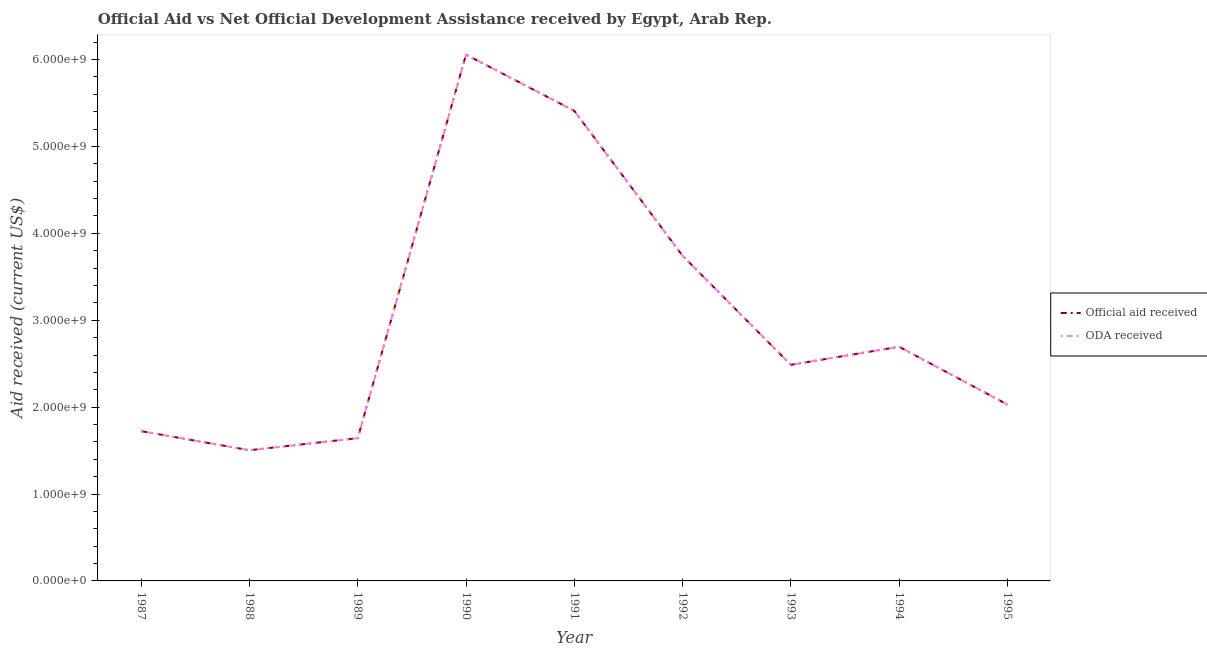Does the line corresponding to oda received intersect with the line corresponding to official aid received?
Provide a short and direct response. Yes. Is the number of lines equal to the number of legend labels?
Provide a succinct answer. Yes. What is the official aid received in 1992?
Offer a terse response. 3.74e+09. Across all years, what is the maximum oda received?
Provide a succinct answer. 6.06e+09. Across all years, what is the minimum oda received?
Offer a very short reply. 1.50e+09. In which year was the official aid received maximum?
Provide a short and direct response. 1990. In which year was the official aid received minimum?
Your answer should be very brief. 1988. What is the total oda received in the graph?
Your response must be concise. 2.73e+1. What is the difference between the official aid received in 1989 and that in 1993?
Your response must be concise. -8.44e+08. What is the difference between the oda received in 1990 and the official aid received in 1987?
Your response must be concise. 4.33e+09. What is the average oda received per year?
Ensure brevity in your answer.  3.03e+09. In the year 1989, what is the difference between the oda received and official aid received?
Ensure brevity in your answer.  0. What is the ratio of the oda received in 1989 to that in 1991?
Provide a short and direct response. 0.3. Is the official aid received in 1991 less than that in 1994?
Offer a terse response. No. What is the difference between the highest and the second highest official aid received?
Offer a terse response. 6.46e+08. What is the difference between the highest and the lowest oda received?
Keep it short and to the point. 4.55e+09. In how many years, is the official aid received greater than the average official aid received taken over all years?
Keep it short and to the point. 3. Is the sum of the official aid received in 1989 and 1992 greater than the maximum oda received across all years?
Make the answer very short. No. Does the oda received monotonically increase over the years?
Provide a short and direct response. No. Is the official aid received strictly greater than the oda received over the years?
Keep it short and to the point. No. Are the values on the major ticks of Y-axis written in scientific E-notation?
Provide a succinct answer. Yes. Does the graph contain grids?
Ensure brevity in your answer.  No. What is the title of the graph?
Ensure brevity in your answer.  Official Aid vs Net Official Development Assistance received by Egypt, Arab Rep. . What is the label or title of the X-axis?
Give a very brief answer. Year. What is the label or title of the Y-axis?
Offer a very short reply. Aid received (current US$). What is the Aid received (current US$) of Official aid received in 1987?
Your response must be concise. 1.72e+09. What is the Aid received (current US$) in ODA received in 1987?
Give a very brief answer. 1.72e+09. What is the Aid received (current US$) in Official aid received in 1988?
Give a very brief answer. 1.50e+09. What is the Aid received (current US$) of ODA received in 1988?
Provide a short and direct response. 1.50e+09. What is the Aid received (current US$) of Official aid received in 1989?
Your answer should be compact. 1.64e+09. What is the Aid received (current US$) of ODA received in 1989?
Your answer should be compact. 1.64e+09. What is the Aid received (current US$) of Official aid received in 1990?
Keep it short and to the point. 6.06e+09. What is the Aid received (current US$) of ODA received in 1990?
Make the answer very short. 6.06e+09. What is the Aid received (current US$) in Official aid received in 1991?
Ensure brevity in your answer.  5.41e+09. What is the Aid received (current US$) of ODA received in 1991?
Keep it short and to the point. 5.41e+09. What is the Aid received (current US$) in Official aid received in 1992?
Offer a terse response. 3.74e+09. What is the Aid received (current US$) in ODA received in 1992?
Offer a terse response. 3.74e+09. What is the Aid received (current US$) of Official aid received in 1993?
Offer a terse response. 2.49e+09. What is the Aid received (current US$) in ODA received in 1993?
Your answer should be very brief. 2.49e+09. What is the Aid received (current US$) of Official aid received in 1994?
Keep it short and to the point. 2.69e+09. What is the Aid received (current US$) of ODA received in 1994?
Your answer should be very brief. 2.69e+09. What is the Aid received (current US$) in Official aid received in 1995?
Offer a terse response. 2.03e+09. What is the Aid received (current US$) of ODA received in 1995?
Give a very brief answer. 2.03e+09. Across all years, what is the maximum Aid received (current US$) in Official aid received?
Your answer should be very brief. 6.06e+09. Across all years, what is the maximum Aid received (current US$) of ODA received?
Provide a succinct answer. 6.06e+09. Across all years, what is the minimum Aid received (current US$) in Official aid received?
Your answer should be very brief. 1.50e+09. Across all years, what is the minimum Aid received (current US$) of ODA received?
Offer a very short reply. 1.50e+09. What is the total Aid received (current US$) in Official aid received in the graph?
Your answer should be very brief. 2.73e+1. What is the total Aid received (current US$) in ODA received in the graph?
Your answer should be compact. 2.73e+1. What is the difference between the Aid received (current US$) in Official aid received in 1987 and that in 1988?
Your response must be concise. 2.19e+08. What is the difference between the Aid received (current US$) of ODA received in 1987 and that in 1988?
Your answer should be very brief. 2.19e+08. What is the difference between the Aid received (current US$) of Official aid received in 1987 and that in 1989?
Make the answer very short. 8.04e+07. What is the difference between the Aid received (current US$) of ODA received in 1987 and that in 1989?
Offer a terse response. 8.04e+07. What is the difference between the Aid received (current US$) in Official aid received in 1987 and that in 1990?
Provide a succinct answer. -4.33e+09. What is the difference between the Aid received (current US$) of ODA received in 1987 and that in 1990?
Your answer should be compact. -4.33e+09. What is the difference between the Aid received (current US$) of Official aid received in 1987 and that in 1991?
Provide a succinct answer. -3.69e+09. What is the difference between the Aid received (current US$) of ODA received in 1987 and that in 1991?
Your response must be concise. -3.69e+09. What is the difference between the Aid received (current US$) of Official aid received in 1987 and that in 1992?
Give a very brief answer. -2.02e+09. What is the difference between the Aid received (current US$) in ODA received in 1987 and that in 1992?
Make the answer very short. -2.02e+09. What is the difference between the Aid received (current US$) of Official aid received in 1987 and that in 1993?
Offer a very short reply. -7.63e+08. What is the difference between the Aid received (current US$) of ODA received in 1987 and that in 1993?
Offer a very short reply. -7.63e+08. What is the difference between the Aid received (current US$) in Official aid received in 1987 and that in 1994?
Ensure brevity in your answer.  -9.71e+08. What is the difference between the Aid received (current US$) in ODA received in 1987 and that in 1994?
Offer a very short reply. -9.71e+08. What is the difference between the Aid received (current US$) in Official aid received in 1987 and that in 1995?
Your answer should be very brief. -3.06e+08. What is the difference between the Aid received (current US$) of ODA received in 1987 and that in 1995?
Your response must be concise. -3.06e+08. What is the difference between the Aid received (current US$) in Official aid received in 1988 and that in 1989?
Your response must be concise. -1.39e+08. What is the difference between the Aid received (current US$) of ODA received in 1988 and that in 1989?
Provide a succinct answer. -1.39e+08. What is the difference between the Aid received (current US$) of Official aid received in 1988 and that in 1990?
Keep it short and to the point. -4.55e+09. What is the difference between the Aid received (current US$) of ODA received in 1988 and that in 1990?
Keep it short and to the point. -4.55e+09. What is the difference between the Aid received (current US$) of Official aid received in 1988 and that in 1991?
Your answer should be very brief. -3.91e+09. What is the difference between the Aid received (current US$) of ODA received in 1988 and that in 1991?
Provide a succinct answer. -3.91e+09. What is the difference between the Aid received (current US$) of Official aid received in 1988 and that in 1992?
Offer a terse response. -2.24e+09. What is the difference between the Aid received (current US$) in ODA received in 1988 and that in 1992?
Your answer should be very brief. -2.24e+09. What is the difference between the Aid received (current US$) of Official aid received in 1988 and that in 1993?
Ensure brevity in your answer.  -9.83e+08. What is the difference between the Aid received (current US$) of ODA received in 1988 and that in 1993?
Keep it short and to the point. -9.83e+08. What is the difference between the Aid received (current US$) of Official aid received in 1988 and that in 1994?
Your response must be concise. -1.19e+09. What is the difference between the Aid received (current US$) of ODA received in 1988 and that in 1994?
Offer a terse response. -1.19e+09. What is the difference between the Aid received (current US$) in Official aid received in 1988 and that in 1995?
Your answer should be very brief. -5.26e+08. What is the difference between the Aid received (current US$) of ODA received in 1988 and that in 1995?
Your answer should be compact. -5.26e+08. What is the difference between the Aid received (current US$) of Official aid received in 1989 and that in 1990?
Offer a very short reply. -4.41e+09. What is the difference between the Aid received (current US$) of ODA received in 1989 and that in 1990?
Offer a very short reply. -4.41e+09. What is the difference between the Aid received (current US$) in Official aid received in 1989 and that in 1991?
Your answer should be compact. -3.77e+09. What is the difference between the Aid received (current US$) in ODA received in 1989 and that in 1991?
Your response must be concise. -3.77e+09. What is the difference between the Aid received (current US$) in Official aid received in 1989 and that in 1992?
Offer a very short reply. -2.10e+09. What is the difference between the Aid received (current US$) of ODA received in 1989 and that in 1992?
Offer a very short reply. -2.10e+09. What is the difference between the Aid received (current US$) in Official aid received in 1989 and that in 1993?
Ensure brevity in your answer.  -8.44e+08. What is the difference between the Aid received (current US$) in ODA received in 1989 and that in 1993?
Give a very brief answer. -8.44e+08. What is the difference between the Aid received (current US$) in Official aid received in 1989 and that in 1994?
Offer a terse response. -1.05e+09. What is the difference between the Aid received (current US$) of ODA received in 1989 and that in 1994?
Ensure brevity in your answer.  -1.05e+09. What is the difference between the Aid received (current US$) in Official aid received in 1989 and that in 1995?
Your answer should be compact. -3.87e+08. What is the difference between the Aid received (current US$) of ODA received in 1989 and that in 1995?
Your answer should be very brief. -3.87e+08. What is the difference between the Aid received (current US$) of Official aid received in 1990 and that in 1991?
Your answer should be compact. 6.46e+08. What is the difference between the Aid received (current US$) of ODA received in 1990 and that in 1991?
Your answer should be compact. 6.46e+08. What is the difference between the Aid received (current US$) in Official aid received in 1990 and that in 1992?
Offer a very short reply. 2.31e+09. What is the difference between the Aid received (current US$) of ODA received in 1990 and that in 1992?
Your answer should be very brief. 2.31e+09. What is the difference between the Aid received (current US$) of Official aid received in 1990 and that in 1993?
Your answer should be very brief. 3.57e+09. What is the difference between the Aid received (current US$) of ODA received in 1990 and that in 1993?
Offer a very short reply. 3.57e+09. What is the difference between the Aid received (current US$) in Official aid received in 1990 and that in 1994?
Provide a succinct answer. 3.36e+09. What is the difference between the Aid received (current US$) in ODA received in 1990 and that in 1994?
Your response must be concise. 3.36e+09. What is the difference between the Aid received (current US$) of Official aid received in 1990 and that in 1995?
Keep it short and to the point. 4.03e+09. What is the difference between the Aid received (current US$) of ODA received in 1990 and that in 1995?
Provide a short and direct response. 4.03e+09. What is the difference between the Aid received (current US$) of Official aid received in 1991 and that in 1992?
Provide a short and direct response. 1.67e+09. What is the difference between the Aid received (current US$) of ODA received in 1991 and that in 1992?
Give a very brief answer. 1.67e+09. What is the difference between the Aid received (current US$) of Official aid received in 1991 and that in 1993?
Give a very brief answer. 2.92e+09. What is the difference between the Aid received (current US$) of ODA received in 1991 and that in 1993?
Give a very brief answer. 2.92e+09. What is the difference between the Aid received (current US$) in Official aid received in 1991 and that in 1994?
Your response must be concise. 2.72e+09. What is the difference between the Aid received (current US$) of ODA received in 1991 and that in 1994?
Your response must be concise. 2.72e+09. What is the difference between the Aid received (current US$) in Official aid received in 1991 and that in 1995?
Provide a succinct answer. 3.38e+09. What is the difference between the Aid received (current US$) of ODA received in 1991 and that in 1995?
Provide a succinct answer. 3.38e+09. What is the difference between the Aid received (current US$) in Official aid received in 1992 and that in 1993?
Provide a succinct answer. 1.26e+09. What is the difference between the Aid received (current US$) in ODA received in 1992 and that in 1993?
Your answer should be compact. 1.26e+09. What is the difference between the Aid received (current US$) of Official aid received in 1992 and that in 1994?
Your answer should be compact. 1.05e+09. What is the difference between the Aid received (current US$) of ODA received in 1992 and that in 1994?
Provide a short and direct response. 1.05e+09. What is the difference between the Aid received (current US$) of Official aid received in 1992 and that in 1995?
Your response must be concise. 1.71e+09. What is the difference between the Aid received (current US$) of ODA received in 1992 and that in 1995?
Your response must be concise. 1.71e+09. What is the difference between the Aid received (current US$) of Official aid received in 1993 and that in 1994?
Provide a succinct answer. -2.08e+08. What is the difference between the Aid received (current US$) of ODA received in 1993 and that in 1994?
Your answer should be compact. -2.08e+08. What is the difference between the Aid received (current US$) in Official aid received in 1993 and that in 1995?
Provide a short and direct response. 4.57e+08. What is the difference between the Aid received (current US$) in ODA received in 1993 and that in 1995?
Offer a very short reply. 4.57e+08. What is the difference between the Aid received (current US$) of Official aid received in 1994 and that in 1995?
Provide a succinct answer. 6.65e+08. What is the difference between the Aid received (current US$) of ODA received in 1994 and that in 1995?
Give a very brief answer. 6.65e+08. What is the difference between the Aid received (current US$) in Official aid received in 1987 and the Aid received (current US$) in ODA received in 1988?
Your answer should be very brief. 2.19e+08. What is the difference between the Aid received (current US$) of Official aid received in 1987 and the Aid received (current US$) of ODA received in 1989?
Provide a short and direct response. 8.04e+07. What is the difference between the Aid received (current US$) of Official aid received in 1987 and the Aid received (current US$) of ODA received in 1990?
Give a very brief answer. -4.33e+09. What is the difference between the Aid received (current US$) of Official aid received in 1987 and the Aid received (current US$) of ODA received in 1991?
Your response must be concise. -3.69e+09. What is the difference between the Aid received (current US$) of Official aid received in 1987 and the Aid received (current US$) of ODA received in 1992?
Give a very brief answer. -2.02e+09. What is the difference between the Aid received (current US$) in Official aid received in 1987 and the Aid received (current US$) in ODA received in 1993?
Your answer should be very brief. -7.63e+08. What is the difference between the Aid received (current US$) of Official aid received in 1987 and the Aid received (current US$) of ODA received in 1994?
Provide a succinct answer. -9.71e+08. What is the difference between the Aid received (current US$) of Official aid received in 1987 and the Aid received (current US$) of ODA received in 1995?
Offer a terse response. -3.06e+08. What is the difference between the Aid received (current US$) of Official aid received in 1988 and the Aid received (current US$) of ODA received in 1989?
Offer a very short reply. -1.39e+08. What is the difference between the Aid received (current US$) in Official aid received in 1988 and the Aid received (current US$) in ODA received in 1990?
Provide a short and direct response. -4.55e+09. What is the difference between the Aid received (current US$) of Official aid received in 1988 and the Aid received (current US$) of ODA received in 1991?
Give a very brief answer. -3.91e+09. What is the difference between the Aid received (current US$) of Official aid received in 1988 and the Aid received (current US$) of ODA received in 1992?
Your response must be concise. -2.24e+09. What is the difference between the Aid received (current US$) in Official aid received in 1988 and the Aid received (current US$) in ODA received in 1993?
Provide a succinct answer. -9.83e+08. What is the difference between the Aid received (current US$) of Official aid received in 1988 and the Aid received (current US$) of ODA received in 1994?
Your response must be concise. -1.19e+09. What is the difference between the Aid received (current US$) in Official aid received in 1988 and the Aid received (current US$) in ODA received in 1995?
Give a very brief answer. -5.26e+08. What is the difference between the Aid received (current US$) of Official aid received in 1989 and the Aid received (current US$) of ODA received in 1990?
Offer a terse response. -4.41e+09. What is the difference between the Aid received (current US$) of Official aid received in 1989 and the Aid received (current US$) of ODA received in 1991?
Your answer should be very brief. -3.77e+09. What is the difference between the Aid received (current US$) of Official aid received in 1989 and the Aid received (current US$) of ODA received in 1992?
Keep it short and to the point. -2.10e+09. What is the difference between the Aid received (current US$) in Official aid received in 1989 and the Aid received (current US$) in ODA received in 1993?
Offer a very short reply. -8.44e+08. What is the difference between the Aid received (current US$) of Official aid received in 1989 and the Aid received (current US$) of ODA received in 1994?
Your response must be concise. -1.05e+09. What is the difference between the Aid received (current US$) in Official aid received in 1989 and the Aid received (current US$) in ODA received in 1995?
Give a very brief answer. -3.87e+08. What is the difference between the Aid received (current US$) of Official aid received in 1990 and the Aid received (current US$) of ODA received in 1991?
Provide a short and direct response. 6.46e+08. What is the difference between the Aid received (current US$) in Official aid received in 1990 and the Aid received (current US$) in ODA received in 1992?
Make the answer very short. 2.31e+09. What is the difference between the Aid received (current US$) of Official aid received in 1990 and the Aid received (current US$) of ODA received in 1993?
Provide a succinct answer. 3.57e+09. What is the difference between the Aid received (current US$) of Official aid received in 1990 and the Aid received (current US$) of ODA received in 1994?
Your answer should be very brief. 3.36e+09. What is the difference between the Aid received (current US$) in Official aid received in 1990 and the Aid received (current US$) in ODA received in 1995?
Your answer should be very brief. 4.03e+09. What is the difference between the Aid received (current US$) in Official aid received in 1991 and the Aid received (current US$) in ODA received in 1992?
Provide a short and direct response. 1.67e+09. What is the difference between the Aid received (current US$) in Official aid received in 1991 and the Aid received (current US$) in ODA received in 1993?
Give a very brief answer. 2.92e+09. What is the difference between the Aid received (current US$) in Official aid received in 1991 and the Aid received (current US$) in ODA received in 1994?
Offer a terse response. 2.72e+09. What is the difference between the Aid received (current US$) in Official aid received in 1991 and the Aid received (current US$) in ODA received in 1995?
Your response must be concise. 3.38e+09. What is the difference between the Aid received (current US$) of Official aid received in 1992 and the Aid received (current US$) of ODA received in 1993?
Make the answer very short. 1.26e+09. What is the difference between the Aid received (current US$) of Official aid received in 1992 and the Aid received (current US$) of ODA received in 1994?
Give a very brief answer. 1.05e+09. What is the difference between the Aid received (current US$) in Official aid received in 1992 and the Aid received (current US$) in ODA received in 1995?
Provide a succinct answer. 1.71e+09. What is the difference between the Aid received (current US$) of Official aid received in 1993 and the Aid received (current US$) of ODA received in 1994?
Offer a very short reply. -2.08e+08. What is the difference between the Aid received (current US$) of Official aid received in 1993 and the Aid received (current US$) of ODA received in 1995?
Ensure brevity in your answer.  4.57e+08. What is the difference between the Aid received (current US$) of Official aid received in 1994 and the Aid received (current US$) of ODA received in 1995?
Your answer should be very brief. 6.65e+08. What is the average Aid received (current US$) in Official aid received per year?
Your response must be concise. 3.03e+09. What is the average Aid received (current US$) of ODA received per year?
Make the answer very short. 3.03e+09. In the year 1987, what is the difference between the Aid received (current US$) in Official aid received and Aid received (current US$) in ODA received?
Your answer should be very brief. 0. In the year 1988, what is the difference between the Aid received (current US$) in Official aid received and Aid received (current US$) in ODA received?
Provide a short and direct response. 0. In the year 1989, what is the difference between the Aid received (current US$) of Official aid received and Aid received (current US$) of ODA received?
Your answer should be very brief. 0. In the year 1991, what is the difference between the Aid received (current US$) in Official aid received and Aid received (current US$) in ODA received?
Your answer should be very brief. 0. In the year 1992, what is the difference between the Aid received (current US$) in Official aid received and Aid received (current US$) in ODA received?
Give a very brief answer. 0. In the year 1994, what is the difference between the Aid received (current US$) in Official aid received and Aid received (current US$) in ODA received?
Your answer should be very brief. 0. In the year 1995, what is the difference between the Aid received (current US$) of Official aid received and Aid received (current US$) of ODA received?
Keep it short and to the point. 0. What is the ratio of the Aid received (current US$) in Official aid received in 1987 to that in 1988?
Ensure brevity in your answer.  1.15. What is the ratio of the Aid received (current US$) in ODA received in 1987 to that in 1988?
Keep it short and to the point. 1.15. What is the ratio of the Aid received (current US$) of Official aid received in 1987 to that in 1989?
Offer a very short reply. 1.05. What is the ratio of the Aid received (current US$) in ODA received in 1987 to that in 1989?
Your answer should be compact. 1.05. What is the ratio of the Aid received (current US$) in Official aid received in 1987 to that in 1990?
Provide a short and direct response. 0.28. What is the ratio of the Aid received (current US$) of ODA received in 1987 to that in 1990?
Make the answer very short. 0.28. What is the ratio of the Aid received (current US$) in Official aid received in 1987 to that in 1991?
Ensure brevity in your answer.  0.32. What is the ratio of the Aid received (current US$) in ODA received in 1987 to that in 1991?
Your answer should be compact. 0.32. What is the ratio of the Aid received (current US$) of Official aid received in 1987 to that in 1992?
Provide a short and direct response. 0.46. What is the ratio of the Aid received (current US$) in ODA received in 1987 to that in 1992?
Make the answer very short. 0.46. What is the ratio of the Aid received (current US$) of Official aid received in 1987 to that in 1993?
Provide a succinct answer. 0.69. What is the ratio of the Aid received (current US$) of ODA received in 1987 to that in 1993?
Provide a short and direct response. 0.69. What is the ratio of the Aid received (current US$) in Official aid received in 1987 to that in 1994?
Ensure brevity in your answer.  0.64. What is the ratio of the Aid received (current US$) of ODA received in 1987 to that in 1994?
Your response must be concise. 0.64. What is the ratio of the Aid received (current US$) in Official aid received in 1987 to that in 1995?
Your answer should be compact. 0.85. What is the ratio of the Aid received (current US$) in ODA received in 1987 to that in 1995?
Make the answer very short. 0.85. What is the ratio of the Aid received (current US$) of Official aid received in 1988 to that in 1989?
Your answer should be very brief. 0.92. What is the ratio of the Aid received (current US$) of ODA received in 1988 to that in 1989?
Provide a short and direct response. 0.92. What is the ratio of the Aid received (current US$) in Official aid received in 1988 to that in 1990?
Give a very brief answer. 0.25. What is the ratio of the Aid received (current US$) of ODA received in 1988 to that in 1990?
Ensure brevity in your answer.  0.25. What is the ratio of the Aid received (current US$) in Official aid received in 1988 to that in 1991?
Make the answer very short. 0.28. What is the ratio of the Aid received (current US$) of ODA received in 1988 to that in 1991?
Give a very brief answer. 0.28. What is the ratio of the Aid received (current US$) in Official aid received in 1988 to that in 1992?
Your response must be concise. 0.4. What is the ratio of the Aid received (current US$) in ODA received in 1988 to that in 1992?
Offer a terse response. 0.4. What is the ratio of the Aid received (current US$) of Official aid received in 1988 to that in 1993?
Offer a very short reply. 0.6. What is the ratio of the Aid received (current US$) of ODA received in 1988 to that in 1993?
Offer a terse response. 0.6. What is the ratio of the Aid received (current US$) in Official aid received in 1988 to that in 1994?
Your answer should be compact. 0.56. What is the ratio of the Aid received (current US$) in ODA received in 1988 to that in 1994?
Ensure brevity in your answer.  0.56. What is the ratio of the Aid received (current US$) of Official aid received in 1988 to that in 1995?
Give a very brief answer. 0.74. What is the ratio of the Aid received (current US$) of ODA received in 1988 to that in 1995?
Your answer should be compact. 0.74. What is the ratio of the Aid received (current US$) in Official aid received in 1989 to that in 1990?
Provide a short and direct response. 0.27. What is the ratio of the Aid received (current US$) of ODA received in 1989 to that in 1990?
Keep it short and to the point. 0.27. What is the ratio of the Aid received (current US$) in Official aid received in 1989 to that in 1991?
Keep it short and to the point. 0.3. What is the ratio of the Aid received (current US$) in ODA received in 1989 to that in 1991?
Make the answer very short. 0.3. What is the ratio of the Aid received (current US$) of Official aid received in 1989 to that in 1992?
Your response must be concise. 0.44. What is the ratio of the Aid received (current US$) of ODA received in 1989 to that in 1992?
Make the answer very short. 0.44. What is the ratio of the Aid received (current US$) in Official aid received in 1989 to that in 1993?
Provide a succinct answer. 0.66. What is the ratio of the Aid received (current US$) in ODA received in 1989 to that in 1993?
Make the answer very short. 0.66. What is the ratio of the Aid received (current US$) in Official aid received in 1989 to that in 1994?
Your response must be concise. 0.61. What is the ratio of the Aid received (current US$) of ODA received in 1989 to that in 1994?
Offer a terse response. 0.61. What is the ratio of the Aid received (current US$) of Official aid received in 1989 to that in 1995?
Your answer should be compact. 0.81. What is the ratio of the Aid received (current US$) of ODA received in 1989 to that in 1995?
Offer a very short reply. 0.81. What is the ratio of the Aid received (current US$) of Official aid received in 1990 to that in 1991?
Ensure brevity in your answer.  1.12. What is the ratio of the Aid received (current US$) of ODA received in 1990 to that in 1991?
Keep it short and to the point. 1.12. What is the ratio of the Aid received (current US$) of Official aid received in 1990 to that in 1992?
Keep it short and to the point. 1.62. What is the ratio of the Aid received (current US$) in ODA received in 1990 to that in 1992?
Ensure brevity in your answer.  1.62. What is the ratio of the Aid received (current US$) in Official aid received in 1990 to that in 1993?
Ensure brevity in your answer.  2.44. What is the ratio of the Aid received (current US$) in ODA received in 1990 to that in 1993?
Provide a short and direct response. 2.44. What is the ratio of the Aid received (current US$) in Official aid received in 1990 to that in 1994?
Your answer should be compact. 2.25. What is the ratio of the Aid received (current US$) of ODA received in 1990 to that in 1994?
Your answer should be compact. 2.25. What is the ratio of the Aid received (current US$) in Official aid received in 1990 to that in 1995?
Your response must be concise. 2.98. What is the ratio of the Aid received (current US$) of ODA received in 1990 to that in 1995?
Your answer should be compact. 2.98. What is the ratio of the Aid received (current US$) in Official aid received in 1991 to that in 1992?
Keep it short and to the point. 1.45. What is the ratio of the Aid received (current US$) of ODA received in 1991 to that in 1992?
Offer a terse response. 1.45. What is the ratio of the Aid received (current US$) of Official aid received in 1991 to that in 1993?
Your answer should be compact. 2.18. What is the ratio of the Aid received (current US$) of ODA received in 1991 to that in 1993?
Your answer should be very brief. 2.18. What is the ratio of the Aid received (current US$) in Official aid received in 1991 to that in 1994?
Ensure brevity in your answer.  2.01. What is the ratio of the Aid received (current US$) of ODA received in 1991 to that in 1994?
Keep it short and to the point. 2.01. What is the ratio of the Aid received (current US$) in Official aid received in 1991 to that in 1995?
Ensure brevity in your answer.  2.67. What is the ratio of the Aid received (current US$) in ODA received in 1991 to that in 1995?
Provide a short and direct response. 2.67. What is the ratio of the Aid received (current US$) of Official aid received in 1992 to that in 1993?
Your answer should be very brief. 1.5. What is the ratio of the Aid received (current US$) of ODA received in 1992 to that in 1993?
Offer a very short reply. 1.5. What is the ratio of the Aid received (current US$) of Official aid received in 1992 to that in 1994?
Provide a short and direct response. 1.39. What is the ratio of the Aid received (current US$) of ODA received in 1992 to that in 1994?
Your answer should be very brief. 1.39. What is the ratio of the Aid received (current US$) in Official aid received in 1992 to that in 1995?
Your answer should be compact. 1.84. What is the ratio of the Aid received (current US$) of ODA received in 1992 to that in 1995?
Keep it short and to the point. 1.84. What is the ratio of the Aid received (current US$) of Official aid received in 1993 to that in 1994?
Keep it short and to the point. 0.92. What is the ratio of the Aid received (current US$) of ODA received in 1993 to that in 1994?
Give a very brief answer. 0.92. What is the ratio of the Aid received (current US$) in Official aid received in 1993 to that in 1995?
Offer a terse response. 1.23. What is the ratio of the Aid received (current US$) in ODA received in 1993 to that in 1995?
Make the answer very short. 1.23. What is the ratio of the Aid received (current US$) of Official aid received in 1994 to that in 1995?
Offer a terse response. 1.33. What is the ratio of the Aid received (current US$) in ODA received in 1994 to that in 1995?
Provide a succinct answer. 1.33. What is the difference between the highest and the second highest Aid received (current US$) of Official aid received?
Make the answer very short. 6.46e+08. What is the difference between the highest and the second highest Aid received (current US$) in ODA received?
Ensure brevity in your answer.  6.46e+08. What is the difference between the highest and the lowest Aid received (current US$) of Official aid received?
Give a very brief answer. 4.55e+09. What is the difference between the highest and the lowest Aid received (current US$) in ODA received?
Offer a very short reply. 4.55e+09. 